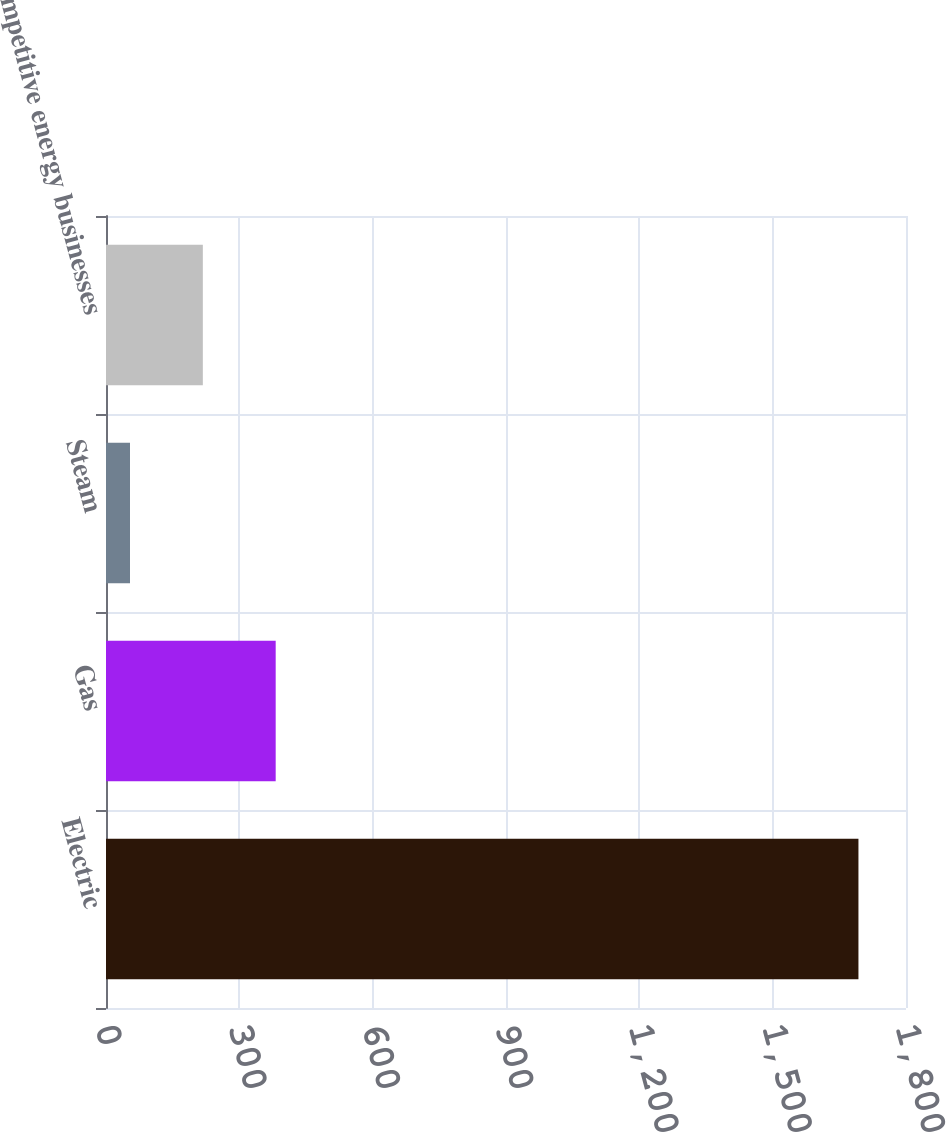<chart> <loc_0><loc_0><loc_500><loc_500><bar_chart><fcel>Electric<fcel>Gas<fcel>Steam<fcel>Competitive energy businesses<nl><fcel>1693<fcel>381.8<fcel>54<fcel>217.9<nl></chart> 